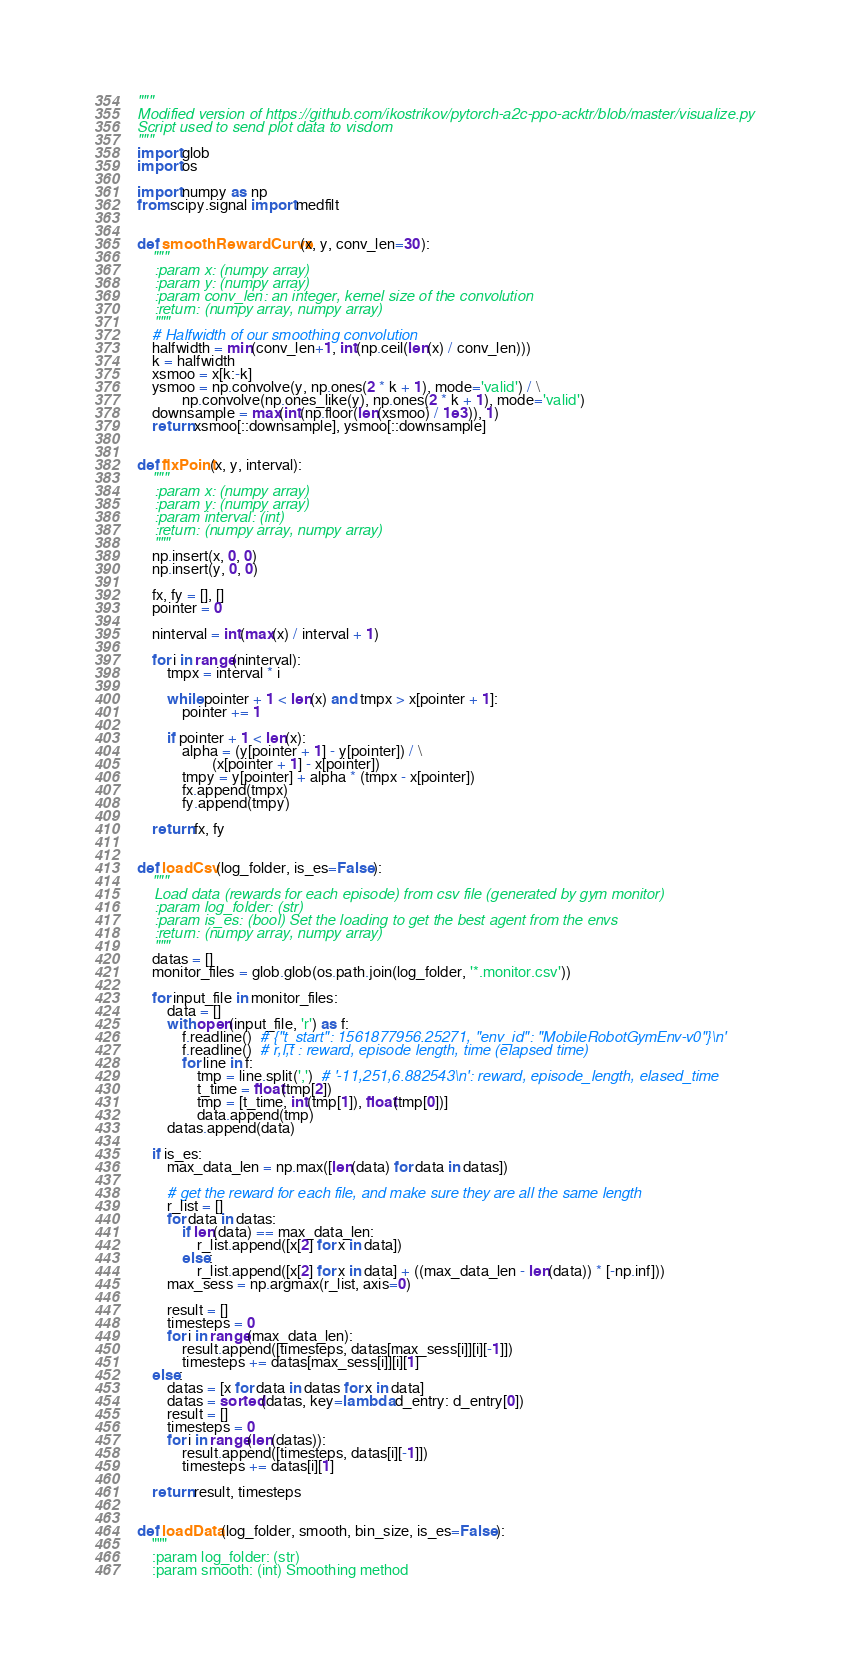Convert code to text. <code><loc_0><loc_0><loc_500><loc_500><_Python_>"""
Modified version of https://github.com/ikostrikov/pytorch-a2c-ppo-acktr/blob/master/visualize.py
Script used to send plot data to visdom
"""
import glob
import os

import numpy as np
from scipy.signal import medfilt


def smoothRewardCurve(x, y, conv_len=30):
    """
    :param x: (numpy array)
    :param y: (numpy array)
    :param conv_len: an integer, kernel size of the convolution
    :return: (numpy array, numpy array)
    """
    # Halfwidth of our smoothing convolution
    halfwidth = min(conv_len+1, int(np.ceil(len(x) / conv_len)))
    k = halfwidth
    xsmoo = x[k:-k]
    ysmoo = np.convolve(y, np.ones(2 * k + 1), mode='valid') / \
            np.convolve(np.ones_like(y), np.ones(2 * k + 1), mode='valid')
    downsample = max(int(np.floor(len(xsmoo) / 1e3)), 1)
    return xsmoo[::downsample], ysmoo[::downsample]


def fixPoint(x, y, interval):
    """
    :param x: (numpy array)
    :param y: (numpy array)
    :param interval: (int)
    :return: (numpy array, numpy array)
    """
    np.insert(x, 0, 0)
    np.insert(y, 0, 0)

    fx, fy = [], []
    pointer = 0

    ninterval = int(max(x) / interval + 1)

    for i in range(ninterval):
        tmpx = interval * i

        while pointer + 1 < len(x) and tmpx > x[pointer + 1]:
            pointer += 1

        if pointer + 1 < len(x):
            alpha = (y[pointer + 1] - y[pointer]) / \
                    (x[pointer + 1] - x[pointer])
            tmpy = y[pointer] + alpha * (tmpx - x[pointer])
            fx.append(tmpx)
            fy.append(tmpy)

    return fx, fy


def loadCsv(log_folder, is_es=False):
    """
    Load data (rewards for each episode) from csv file (generated by gym monitor)
    :param log_folder: (str)
    :param is_es: (bool) Set the loading to get the best agent from the envs
    :return: (numpy array, numpy array)
    """
    datas = []
    monitor_files = glob.glob(os.path.join(log_folder, '*.monitor.csv'))

    for input_file in monitor_files:
        data = []
        with open(input_file, 'r') as f:
            f.readline()  # {"t_start": 1561877956.25271, "env_id": "MobileRobotGymEnv-v0"}\n'
            f.readline()  # r,l,t : reward, episode length, time (elapsed time)
            for line in f:
                tmp = line.split(',')  # '-11,251,6.882543\n': reward, episode_length, elased_time
                t_time = float(tmp[2])
                tmp = [t_time, int(tmp[1]), float(tmp[0])]
                data.append(tmp)
        datas.append(data)

    if is_es:
        max_data_len = np.max([len(data) for data in datas])

        # get the reward for each file, and make sure they are all the same length
        r_list = []
        for data in datas:
            if len(data) == max_data_len:
                r_list.append([x[2] for x in data])
            else:
                r_list.append([x[2] for x in data] + ((max_data_len - len(data)) * [-np.inf]))
        max_sess = np.argmax(r_list, axis=0)

        result = []
        timesteps = 0
        for i in range(max_data_len):
            result.append([timesteps, datas[max_sess[i]][i][-1]])
            timesteps += datas[max_sess[i]][i][1]
    else:
        datas = [x for data in datas for x in data]
        datas = sorted(datas, key=lambda d_entry: d_entry[0])
        result = []
        timesteps = 0
        for i in range(len(datas)):
            result.append([timesteps, datas[i][-1]])
            timesteps += datas[i][1]

    return result, timesteps


def loadData(log_folder, smooth, bin_size, is_es=False):
    """
    :param log_folder: (str)
    :param smooth: (int) Smoothing method</code> 